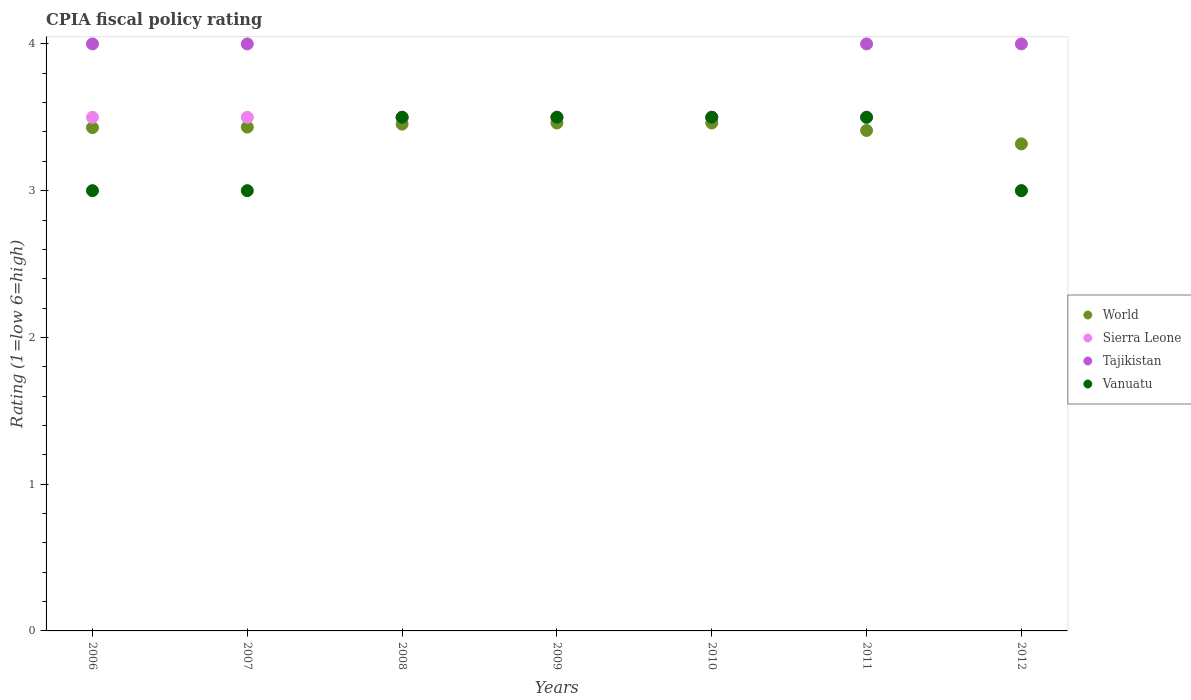Is the number of dotlines equal to the number of legend labels?
Your response must be concise. Yes. What is the CPIA rating in Vanuatu in 2010?
Your answer should be compact. 3.5. Across all years, what is the maximum CPIA rating in World?
Give a very brief answer. 3.46. Across all years, what is the minimum CPIA rating in Sierra Leone?
Ensure brevity in your answer.  3. In which year was the CPIA rating in World maximum?
Offer a very short reply. 2009. In which year was the CPIA rating in Sierra Leone minimum?
Your answer should be very brief. 2012. What is the total CPIA rating in World in the graph?
Provide a short and direct response. 23.97. What is the difference between the CPIA rating in Sierra Leone in 2008 and that in 2012?
Provide a succinct answer. 0.5. What is the average CPIA rating in World per year?
Offer a very short reply. 3.42. What is the ratio of the CPIA rating in Sierra Leone in 2008 to that in 2012?
Provide a short and direct response. 1.17. Is the CPIA rating in World in 2008 less than that in 2010?
Offer a terse response. Yes. Is the difference between the CPIA rating in Sierra Leone in 2006 and 2011 greater than the difference between the CPIA rating in Tajikistan in 2006 and 2011?
Offer a terse response. No. What is the difference between the highest and the second highest CPIA rating in World?
Provide a succinct answer. 0. What is the difference between the highest and the lowest CPIA rating in Vanuatu?
Your response must be concise. 0.5. In how many years, is the CPIA rating in Vanuatu greater than the average CPIA rating in Vanuatu taken over all years?
Offer a very short reply. 4. Is the CPIA rating in Sierra Leone strictly greater than the CPIA rating in World over the years?
Your response must be concise. No. How many years are there in the graph?
Provide a succinct answer. 7. What is the difference between two consecutive major ticks on the Y-axis?
Your answer should be compact. 1. Does the graph contain any zero values?
Offer a very short reply. No. Does the graph contain grids?
Offer a very short reply. No. Where does the legend appear in the graph?
Keep it short and to the point. Center right. How many legend labels are there?
Offer a terse response. 4. What is the title of the graph?
Your response must be concise. CPIA fiscal policy rating. What is the label or title of the Y-axis?
Provide a succinct answer. Rating (1=low 6=high). What is the Rating (1=low 6=high) of World in 2006?
Offer a very short reply. 3.43. What is the Rating (1=low 6=high) in Sierra Leone in 2006?
Your answer should be compact. 3.5. What is the Rating (1=low 6=high) of Tajikistan in 2006?
Your response must be concise. 4. What is the Rating (1=low 6=high) of World in 2007?
Ensure brevity in your answer.  3.43. What is the Rating (1=low 6=high) of Sierra Leone in 2007?
Your answer should be very brief. 3.5. What is the Rating (1=low 6=high) of Tajikistan in 2007?
Your response must be concise. 4. What is the Rating (1=low 6=high) in Vanuatu in 2007?
Your answer should be compact. 3. What is the Rating (1=low 6=high) in World in 2008?
Offer a terse response. 3.45. What is the Rating (1=low 6=high) in Tajikistan in 2008?
Offer a terse response. 3.5. What is the Rating (1=low 6=high) in Vanuatu in 2008?
Keep it short and to the point. 3.5. What is the Rating (1=low 6=high) of World in 2009?
Offer a very short reply. 3.46. What is the Rating (1=low 6=high) of World in 2010?
Offer a terse response. 3.46. What is the Rating (1=low 6=high) in Tajikistan in 2010?
Keep it short and to the point. 3.5. What is the Rating (1=low 6=high) of World in 2011?
Your answer should be very brief. 3.41. What is the Rating (1=low 6=high) of Tajikistan in 2011?
Provide a short and direct response. 4. What is the Rating (1=low 6=high) of World in 2012?
Offer a terse response. 3.32. What is the Rating (1=low 6=high) in Tajikistan in 2012?
Offer a very short reply. 4. What is the Rating (1=low 6=high) of Vanuatu in 2012?
Your response must be concise. 3. Across all years, what is the maximum Rating (1=low 6=high) in World?
Your answer should be compact. 3.46. Across all years, what is the maximum Rating (1=low 6=high) in Tajikistan?
Provide a succinct answer. 4. Across all years, what is the minimum Rating (1=low 6=high) in World?
Make the answer very short. 3.32. Across all years, what is the minimum Rating (1=low 6=high) in Sierra Leone?
Ensure brevity in your answer.  3. Across all years, what is the minimum Rating (1=low 6=high) of Vanuatu?
Keep it short and to the point. 3. What is the total Rating (1=low 6=high) in World in the graph?
Ensure brevity in your answer.  23.97. What is the difference between the Rating (1=low 6=high) of World in 2006 and that in 2007?
Your response must be concise. -0. What is the difference between the Rating (1=low 6=high) of Tajikistan in 2006 and that in 2007?
Your response must be concise. 0. What is the difference between the Rating (1=low 6=high) of World in 2006 and that in 2008?
Your response must be concise. -0.02. What is the difference between the Rating (1=low 6=high) in Tajikistan in 2006 and that in 2008?
Your answer should be very brief. 0.5. What is the difference between the Rating (1=low 6=high) of World in 2006 and that in 2009?
Give a very brief answer. -0.03. What is the difference between the Rating (1=low 6=high) of Sierra Leone in 2006 and that in 2009?
Provide a short and direct response. 0. What is the difference between the Rating (1=low 6=high) of World in 2006 and that in 2010?
Keep it short and to the point. -0.03. What is the difference between the Rating (1=low 6=high) of Sierra Leone in 2006 and that in 2010?
Ensure brevity in your answer.  0. What is the difference between the Rating (1=low 6=high) of Tajikistan in 2006 and that in 2010?
Give a very brief answer. 0.5. What is the difference between the Rating (1=low 6=high) in World in 2006 and that in 2011?
Your answer should be compact. 0.02. What is the difference between the Rating (1=low 6=high) in Sierra Leone in 2006 and that in 2011?
Provide a succinct answer. 0. What is the difference between the Rating (1=low 6=high) of Vanuatu in 2006 and that in 2011?
Your answer should be very brief. -0.5. What is the difference between the Rating (1=low 6=high) of World in 2006 and that in 2012?
Your answer should be very brief. 0.11. What is the difference between the Rating (1=low 6=high) in Tajikistan in 2006 and that in 2012?
Ensure brevity in your answer.  0. What is the difference between the Rating (1=low 6=high) in Vanuatu in 2006 and that in 2012?
Your answer should be very brief. 0. What is the difference between the Rating (1=low 6=high) in World in 2007 and that in 2008?
Provide a succinct answer. -0.02. What is the difference between the Rating (1=low 6=high) in Sierra Leone in 2007 and that in 2008?
Provide a succinct answer. 0. What is the difference between the Rating (1=low 6=high) of Tajikistan in 2007 and that in 2008?
Make the answer very short. 0.5. What is the difference between the Rating (1=low 6=high) of Vanuatu in 2007 and that in 2008?
Make the answer very short. -0.5. What is the difference between the Rating (1=low 6=high) of World in 2007 and that in 2009?
Provide a succinct answer. -0.03. What is the difference between the Rating (1=low 6=high) in Sierra Leone in 2007 and that in 2009?
Ensure brevity in your answer.  0. What is the difference between the Rating (1=low 6=high) of Tajikistan in 2007 and that in 2009?
Your answer should be compact. 0.5. What is the difference between the Rating (1=low 6=high) in World in 2007 and that in 2010?
Give a very brief answer. -0.03. What is the difference between the Rating (1=low 6=high) in Tajikistan in 2007 and that in 2010?
Offer a terse response. 0.5. What is the difference between the Rating (1=low 6=high) of Vanuatu in 2007 and that in 2010?
Your answer should be very brief. -0.5. What is the difference between the Rating (1=low 6=high) of World in 2007 and that in 2011?
Your answer should be compact. 0.02. What is the difference between the Rating (1=low 6=high) in Sierra Leone in 2007 and that in 2011?
Provide a succinct answer. 0. What is the difference between the Rating (1=low 6=high) of Tajikistan in 2007 and that in 2011?
Ensure brevity in your answer.  0. What is the difference between the Rating (1=low 6=high) of Vanuatu in 2007 and that in 2011?
Keep it short and to the point. -0.5. What is the difference between the Rating (1=low 6=high) of World in 2007 and that in 2012?
Offer a very short reply. 0.11. What is the difference between the Rating (1=low 6=high) in Tajikistan in 2007 and that in 2012?
Your response must be concise. 0. What is the difference between the Rating (1=low 6=high) in Vanuatu in 2007 and that in 2012?
Give a very brief answer. 0. What is the difference between the Rating (1=low 6=high) in World in 2008 and that in 2009?
Ensure brevity in your answer.  -0.01. What is the difference between the Rating (1=low 6=high) of World in 2008 and that in 2010?
Provide a short and direct response. -0.01. What is the difference between the Rating (1=low 6=high) in Tajikistan in 2008 and that in 2010?
Provide a succinct answer. 0. What is the difference between the Rating (1=low 6=high) in World in 2008 and that in 2011?
Provide a short and direct response. 0.04. What is the difference between the Rating (1=low 6=high) in Sierra Leone in 2008 and that in 2011?
Give a very brief answer. 0. What is the difference between the Rating (1=low 6=high) in Vanuatu in 2008 and that in 2011?
Keep it short and to the point. 0. What is the difference between the Rating (1=low 6=high) in World in 2008 and that in 2012?
Ensure brevity in your answer.  0.13. What is the difference between the Rating (1=low 6=high) of Sierra Leone in 2008 and that in 2012?
Your answer should be compact. 0.5. What is the difference between the Rating (1=low 6=high) of Vanuatu in 2008 and that in 2012?
Provide a succinct answer. 0.5. What is the difference between the Rating (1=low 6=high) in Tajikistan in 2009 and that in 2010?
Provide a succinct answer. 0. What is the difference between the Rating (1=low 6=high) in Vanuatu in 2009 and that in 2010?
Give a very brief answer. 0. What is the difference between the Rating (1=low 6=high) of World in 2009 and that in 2011?
Ensure brevity in your answer.  0.05. What is the difference between the Rating (1=low 6=high) of Tajikistan in 2009 and that in 2011?
Your answer should be compact. -0.5. What is the difference between the Rating (1=low 6=high) in Vanuatu in 2009 and that in 2011?
Offer a terse response. 0. What is the difference between the Rating (1=low 6=high) of World in 2009 and that in 2012?
Your answer should be very brief. 0.14. What is the difference between the Rating (1=low 6=high) of Sierra Leone in 2009 and that in 2012?
Keep it short and to the point. 0.5. What is the difference between the Rating (1=low 6=high) of Tajikistan in 2009 and that in 2012?
Offer a terse response. -0.5. What is the difference between the Rating (1=low 6=high) in Vanuatu in 2009 and that in 2012?
Ensure brevity in your answer.  0.5. What is the difference between the Rating (1=low 6=high) in World in 2010 and that in 2011?
Provide a short and direct response. 0.05. What is the difference between the Rating (1=low 6=high) of Sierra Leone in 2010 and that in 2011?
Your response must be concise. 0. What is the difference between the Rating (1=low 6=high) in Tajikistan in 2010 and that in 2011?
Your response must be concise. -0.5. What is the difference between the Rating (1=low 6=high) of World in 2010 and that in 2012?
Offer a very short reply. 0.14. What is the difference between the Rating (1=low 6=high) in Sierra Leone in 2010 and that in 2012?
Give a very brief answer. 0.5. What is the difference between the Rating (1=low 6=high) in Tajikistan in 2010 and that in 2012?
Offer a terse response. -0.5. What is the difference between the Rating (1=low 6=high) of Vanuatu in 2010 and that in 2012?
Your response must be concise. 0.5. What is the difference between the Rating (1=low 6=high) of World in 2011 and that in 2012?
Ensure brevity in your answer.  0.09. What is the difference between the Rating (1=low 6=high) of Sierra Leone in 2011 and that in 2012?
Your answer should be compact. 0.5. What is the difference between the Rating (1=low 6=high) of Tajikistan in 2011 and that in 2012?
Your response must be concise. 0. What is the difference between the Rating (1=low 6=high) in Vanuatu in 2011 and that in 2012?
Keep it short and to the point. 0.5. What is the difference between the Rating (1=low 6=high) of World in 2006 and the Rating (1=low 6=high) of Sierra Leone in 2007?
Provide a short and direct response. -0.07. What is the difference between the Rating (1=low 6=high) of World in 2006 and the Rating (1=low 6=high) of Tajikistan in 2007?
Make the answer very short. -0.57. What is the difference between the Rating (1=low 6=high) in World in 2006 and the Rating (1=low 6=high) in Vanuatu in 2007?
Your answer should be compact. 0.43. What is the difference between the Rating (1=low 6=high) of Sierra Leone in 2006 and the Rating (1=low 6=high) of Vanuatu in 2007?
Your response must be concise. 0.5. What is the difference between the Rating (1=low 6=high) in World in 2006 and the Rating (1=low 6=high) in Sierra Leone in 2008?
Your response must be concise. -0.07. What is the difference between the Rating (1=low 6=high) in World in 2006 and the Rating (1=low 6=high) in Tajikistan in 2008?
Give a very brief answer. -0.07. What is the difference between the Rating (1=low 6=high) in World in 2006 and the Rating (1=low 6=high) in Vanuatu in 2008?
Provide a succinct answer. -0.07. What is the difference between the Rating (1=low 6=high) in Sierra Leone in 2006 and the Rating (1=low 6=high) in Tajikistan in 2008?
Give a very brief answer. 0. What is the difference between the Rating (1=low 6=high) in World in 2006 and the Rating (1=low 6=high) in Sierra Leone in 2009?
Provide a succinct answer. -0.07. What is the difference between the Rating (1=low 6=high) of World in 2006 and the Rating (1=low 6=high) of Tajikistan in 2009?
Ensure brevity in your answer.  -0.07. What is the difference between the Rating (1=low 6=high) in World in 2006 and the Rating (1=low 6=high) in Vanuatu in 2009?
Keep it short and to the point. -0.07. What is the difference between the Rating (1=low 6=high) in World in 2006 and the Rating (1=low 6=high) in Sierra Leone in 2010?
Ensure brevity in your answer.  -0.07. What is the difference between the Rating (1=low 6=high) of World in 2006 and the Rating (1=low 6=high) of Tajikistan in 2010?
Offer a very short reply. -0.07. What is the difference between the Rating (1=low 6=high) in World in 2006 and the Rating (1=low 6=high) in Vanuatu in 2010?
Your answer should be very brief. -0.07. What is the difference between the Rating (1=low 6=high) of Sierra Leone in 2006 and the Rating (1=low 6=high) of Tajikistan in 2010?
Provide a succinct answer. 0. What is the difference between the Rating (1=low 6=high) in Sierra Leone in 2006 and the Rating (1=low 6=high) in Vanuatu in 2010?
Your answer should be very brief. 0. What is the difference between the Rating (1=low 6=high) in World in 2006 and the Rating (1=low 6=high) in Sierra Leone in 2011?
Offer a terse response. -0.07. What is the difference between the Rating (1=low 6=high) in World in 2006 and the Rating (1=low 6=high) in Tajikistan in 2011?
Provide a succinct answer. -0.57. What is the difference between the Rating (1=low 6=high) in World in 2006 and the Rating (1=low 6=high) in Vanuatu in 2011?
Your answer should be very brief. -0.07. What is the difference between the Rating (1=low 6=high) in Sierra Leone in 2006 and the Rating (1=low 6=high) in Tajikistan in 2011?
Ensure brevity in your answer.  -0.5. What is the difference between the Rating (1=low 6=high) of Sierra Leone in 2006 and the Rating (1=low 6=high) of Vanuatu in 2011?
Offer a very short reply. 0. What is the difference between the Rating (1=low 6=high) of World in 2006 and the Rating (1=low 6=high) of Sierra Leone in 2012?
Your answer should be compact. 0.43. What is the difference between the Rating (1=low 6=high) in World in 2006 and the Rating (1=low 6=high) in Tajikistan in 2012?
Your answer should be compact. -0.57. What is the difference between the Rating (1=low 6=high) of World in 2006 and the Rating (1=low 6=high) of Vanuatu in 2012?
Your response must be concise. 0.43. What is the difference between the Rating (1=low 6=high) of World in 2007 and the Rating (1=low 6=high) of Sierra Leone in 2008?
Your response must be concise. -0.07. What is the difference between the Rating (1=low 6=high) of World in 2007 and the Rating (1=low 6=high) of Tajikistan in 2008?
Your answer should be compact. -0.07. What is the difference between the Rating (1=low 6=high) in World in 2007 and the Rating (1=low 6=high) in Vanuatu in 2008?
Offer a terse response. -0.07. What is the difference between the Rating (1=low 6=high) of Sierra Leone in 2007 and the Rating (1=low 6=high) of Tajikistan in 2008?
Make the answer very short. 0. What is the difference between the Rating (1=low 6=high) in Sierra Leone in 2007 and the Rating (1=low 6=high) in Vanuatu in 2008?
Offer a terse response. 0. What is the difference between the Rating (1=low 6=high) of Tajikistan in 2007 and the Rating (1=low 6=high) of Vanuatu in 2008?
Your response must be concise. 0.5. What is the difference between the Rating (1=low 6=high) in World in 2007 and the Rating (1=low 6=high) in Sierra Leone in 2009?
Offer a terse response. -0.07. What is the difference between the Rating (1=low 6=high) of World in 2007 and the Rating (1=low 6=high) of Tajikistan in 2009?
Make the answer very short. -0.07. What is the difference between the Rating (1=low 6=high) in World in 2007 and the Rating (1=low 6=high) in Vanuatu in 2009?
Keep it short and to the point. -0.07. What is the difference between the Rating (1=low 6=high) in Sierra Leone in 2007 and the Rating (1=low 6=high) in Tajikistan in 2009?
Your answer should be compact. 0. What is the difference between the Rating (1=low 6=high) in Sierra Leone in 2007 and the Rating (1=low 6=high) in Vanuatu in 2009?
Your response must be concise. 0. What is the difference between the Rating (1=low 6=high) of Tajikistan in 2007 and the Rating (1=low 6=high) of Vanuatu in 2009?
Make the answer very short. 0.5. What is the difference between the Rating (1=low 6=high) in World in 2007 and the Rating (1=low 6=high) in Sierra Leone in 2010?
Provide a short and direct response. -0.07. What is the difference between the Rating (1=low 6=high) of World in 2007 and the Rating (1=low 6=high) of Tajikistan in 2010?
Your response must be concise. -0.07. What is the difference between the Rating (1=low 6=high) in World in 2007 and the Rating (1=low 6=high) in Vanuatu in 2010?
Ensure brevity in your answer.  -0.07. What is the difference between the Rating (1=low 6=high) in Sierra Leone in 2007 and the Rating (1=low 6=high) in Tajikistan in 2010?
Offer a terse response. 0. What is the difference between the Rating (1=low 6=high) of World in 2007 and the Rating (1=low 6=high) of Sierra Leone in 2011?
Provide a short and direct response. -0.07. What is the difference between the Rating (1=low 6=high) in World in 2007 and the Rating (1=low 6=high) in Tajikistan in 2011?
Give a very brief answer. -0.57. What is the difference between the Rating (1=low 6=high) in World in 2007 and the Rating (1=low 6=high) in Vanuatu in 2011?
Provide a succinct answer. -0.07. What is the difference between the Rating (1=low 6=high) of World in 2007 and the Rating (1=low 6=high) of Sierra Leone in 2012?
Make the answer very short. 0.43. What is the difference between the Rating (1=low 6=high) in World in 2007 and the Rating (1=low 6=high) in Tajikistan in 2012?
Offer a very short reply. -0.57. What is the difference between the Rating (1=low 6=high) of World in 2007 and the Rating (1=low 6=high) of Vanuatu in 2012?
Offer a terse response. 0.43. What is the difference between the Rating (1=low 6=high) in Sierra Leone in 2007 and the Rating (1=low 6=high) in Tajikistan in 2012?
Offer a terse response. -0.5. What is the difference between the Rating (1=low 6=high) of Sierra Leone in 2007 and the Rating (1=low 6=high) of Vanuatu in 2012?
Ensure brevity in your answer.  0.5. What is the difference between the Rating (1=low 6=high) of World in 2008 and the Rating (1=low 6=high) of Sierra Leone in 2009?
Offer a very short reply. -0.05. What is the difference between the Rating (1=low 6=high) in World in 2008 and the Rating (1=low 6=high) in Tajikistan in 2009?
Your response must be concise. -0.05. What is the difference between the Rating (1=low 6=high) of World in 2008 and the Rating (1=low 6=high) of Vanuatu in 2009?
Your answer should be very brief. -0.05. What is the difference between the Rating (1=low 6=high) of Sierra Leone in 2008 and the Rating (1=low 6=high) of Tajikistan in 2009?
Ensure brevity in your answer.  0. What is the difference between the Rating (1=low 6=high) of World in 2008 and the Rating (1=low 6=high) of Sierra Leone in 2010?
Your answer should be compact. -0.05. What is the difference between the Rating (1=low 6=high) of World in 2008 and the Rating (1=low 6=high) of Tajikistan in 2010?
Your response must be concise. -0.05. What is the difference between the Rating (1=low 6=high) of World in 2008 and the Rating (1=low 6=high) of Vanuatu in 2010?
Give a very brief answer. -0.05. What is the difference between the Rating (1=low 6=high) in World in 2008 and the Rating (1=low 6=high) in Sierra Leone in 2011?
Ensure brevity in your answer.  -0.05. What is the difference between the Rating (1=low 6=high) in World in 2008 and the Rating (1=low 6=high) in Tajikistan in 2011?
Your answer should be compact. -0.55. What is the difference between the Rating (1=low 6=high) of World in 2008 and the Rating (1=low 6=high) of Vanuatu in 2011?
Make the answer very short. -0.05. What is the difference between the Rating (1=low 6=high) of Sierra Leone in 2008 and the Rating (1=low 6=high) of Tajikistan in 2011?
Offer a very short reply. -0.5. What is the difference between the Rating (1=low 6=high) in Sierra Leone in 2008 and the Rating (1=low 6=high) in Vanuatu in 2011?
Keep it short and to the point. 0. What is the difference between the Rating (1=low 6=high) of World in 2008 and the Rating (1=low 6=high) of Sierra Leone in 2012?
Ensure brevity in your answer.  0.45. What is the difference between the Rating (1=low 6=high) of World in 2008 and the Rating (1=low 6=high) of Tajikistan in 2012?
Provide a succinct answer. -0.55. What is the difference between the Rating (1=low 6=high) of World in 2008 and the Rating (1=low 6=high) of Vanuatu in 2012?
Give a very brief answer. 0.45. What is the difference between the Rating (1=low 6=high) in Sierra Leone in 2008 and the Rating (1=low 6=high) in Vanuatu in 2012?
Provide a succinct answer. 0.5. What is the difference between the Rating (1=low 6=high) of World in 2009 and the Rating (1=low 6=high) of Sierra Leone in 2010?
Keep it short and to the point. -0.04. What is the difference between the Rating (1=low 6=high) of World in 2009 and the Rating (1=low 6=high) of Tajikistan in 2010?
Give a very brief answer. -0.04. What is the difference between the Rating (1=low 6=high) in World in 2009 and the Rating (1=low 6=high) in Vanuatu in 2010?
Keep it short and to the point. -0.04. What is the difference between the Rating (1=low 6=high) in Sierra Leone in 2009 and the Rating (1=low 6=high) in Tajikistan in 2010?
Provide a succinct answer. 0. What is the difference between the Rating (1=low 6=high) of Sierra Leone in 2009 and the Rating (1=low 6=high) of Vanuatu in 2010?
Ensure brevity in your answer.  0. What is the difference between the Rating (1=low 6=high) of Tajikistan in 2009 and the Rating (1=low 6=high) of Vanuatu in 2010?
Give a very brief answer. 0. What is the difference between the Rating (1=low 6=high) of World in 2009 and the Rating (1=low 6=high) of Sierra Leone in 2011?
Your answer should be compact. -0.04. What is the difference between the Rating (1=low 6=high) in World in 2009 and the Rating (1=low 6=high) in Tajikistan in 2011?
Your answer should be very brief. -0.54. What is the difference between the Rating (1=low 6=high) of World in 2009 and the Rating (1=low 6=high) of Vanuatu in 2011?
Offer a terse response. -0.04. What is the difference between the Rating (1=low 6=high) in Sierra Leone in 2009 and the Rating (1=low 6=high) in Vanuatu in 2011?
Provide a succinct answer. 0. What is the difference between the Rating (1=low 6=high) in Tajikistan in 2009 and the Rating (1=low 6=high) in Vanuatu in 2011?
Provide a succinct answer. 0. What is the difference between the Rating (1=low 6=high) of World in 2009 and the Rating (1=low 6=high) of Sierra Leone in 2012?
Ensure brevity in your answer.  0.46. What is the difference between the Rating (1=low 6=high) in World in 2009 and the Rating (1=low 6=high) in Tajikistan in 2012?
Provide a succinct answer. -0.54. What is the difference between the Rating (1=low 6=high) of World in 2009 and the Rating (1=low 6=high) of Vanuatu in 2012?
Your response must be concise. 0.46. What is the difference between the Rating (1=low 6=high) in Sierra Leone in 2009 and the Rating (1=low 6=high) in Tajikistan in 2012?
Offer a very short reply. -0.5. What is the difference between the Rating (1=low 6=high) in World in 2010 and the Rating (1=low 6=high) in Sierra Leone in 2011?
Provide a succinct answer. -0.04. What is the difference between the Rating (1=low 6=high) of World in 2010 and the Rating (1=low 6=high) of Tajikistan in 2011?
Provide a succinct answer. -0.54. What is the difference between the Rating (1=low 6=high) in World in 2010 and the Rating (1=low 6=high) in Vanuatu in 2011?
Your answer should be very brief. -0.04. What is the difference between the Rating (1=low 6=high) of Sierra Leone in 2010 and the Rating (1=low 6=high) of Tajikistan in 2011?
Your response must be concise. -0.5. What is the difference between the Rating (1=low 6=high) in World in 2010 and the Rating (1=low 6=high) in Sierra Leone in 2012?
Provide a short and direct response. 0.46. What is the difference between the Rating (1=low 6=high) in World in 2010 and the Rating (1=low 6=high) in Tajikistan in 2012?
Ensure brevity in your answer.  -0.54. What is the difference between the Rating (1=low 6=high) of World in 2010 and the Rating (1=low 6=high) of Vanuatu in 2012?
Make the answer very short. 0.46. What is the difference between the Rating (1=low 6=high) in Sierra Leone in 2010 and the Rating (1=low 6=high) in Tajikistan in 2012?
Ensure brevity in your answer.  -0.5. What is the difference between the Rating (1=low 6=high) of Sierra Leone in 2010 and the Rating (1=low 6=high) of Vanuatu in 2012?
Your response must be concise. 0.5. What is the difference between the Rating (1=low 6=high) of Tajikistan in 2010 and the Rating (1=low 6=high) of Vanuatu in 2012?
Your answer should be compact. 0.5. What is the difference between the Rating (1=low 6=high) of World in 2011 and the Rating (1=low 6=high) of Sierra Leone in 2012?
Your answer should be compact. 0.41. What is the difference between the Rating (1=low 6=high) of World in 2011 and the Rating (1=low 6=high) of Tajikistan in 2012?
Your answer should be very brief. -0.59. What is the difference between the Rating (1=low 6=high) in World in 2011 and the Rating (1=low 6=high) in Vanuatu in 2012?
Provide a succinct answer. 0.41. What is the average Rating (1=low 6=high) of World per year?
Provide a succinct answer. 3.42. What is the average Rating (1=low 6=high) of Sierra Leone per year?
Provide a succinct answer. 3.43. What is the average Rating (1=low 6=high) in Tajikistan per year?
Offer a terse response. 3.79. What is the average Rating (1=low 6=high) in Vanuatu per year?
Your answer should be very brief. 3.29. In the year 2006, what is the difference between the Rating (1=low 6=high) of World and Rating (1=low 6=high) of Sierra Leone?
Ensure brevity in your answer.  -0.07. In the year 2006, what is the difference between the Rating (1=low 6=high) of World and Rating (1=low 6=high) of Tajikistan?
Make the answer very short. -0.57. In the year 2006, what is the difference between the Rating (1=low 6=high) of World and Rating (1=low 6=high) of Vanuatu?
Provide a short and direct response. 0.43. In the year 2007, what is the difference between the Rating (1=low 6=high) in World and Rating (1=low 6=high) in Sierra Leone?
Ensure brevity in your answer.  -0.07. In the year 2007, what is the difference between the Rating (1=low 6=high) of World and Rating (1=low 6=high) of Tajikistan?
Provide a short and direct response. -0.57. In the year 2007, what is the difference between the Rating (1=low 6=high) of World and Rating (1=low 6=high) of Vanuatu?
Your answer should be compact. 0.43. In the year 2007, what is the difference between the Rating (1=low 6=high) in Sierra Leone and Rating (1=low 6=high) in Vanuatu?
Give a very brief answer. 0.5. In the year 2007, what is the difference between the Rating (1=low 6=high) in Tajikistan and Rating (1=low 6=high) in Vanuatu?
Provide a short and direct response. 1. In the year 2008, what is the difference between the Rating (1=low 6=high) of World and Rating (1=low 6=high) of Sierra Leone?
Make the answer very short. -0.05. In the year 2008, what is the difference between the Rating (1=low 6=high) of World and Rating (1=low 6=high) of Tajikistan?
Keep it short and to the point. -0.05. In the year 2008, what is the difference between the Rating (1=low 6=high) in World and Rating (1=low 6=high) in Vanuatu?
Give a very brief answer. -0.05. In the year 2009, what is the difference between the Rating (1=low 6=high) in World and Rating (1=low 6=high) in Sierra Leone?
Provide a succinct answer. -0.04. In the year 2009, what is the difference between the Rating (1=low 6=high) of World and Rating (1=low 6=high) of Tajikistan?
Provide a short and direct response. -0.04. In the year 2009, what is the difference between the Rating (1=low 6=high) of World and Rating (1=low 6=high) of Vanuatu?
Give a very brief answer. -0.04. In the year 2009, what is the difference between the Rating (1=low 6=high) of Sierra Leone and Rating (1=low 6=high) of Tajikistan?
Keep it short and to the point. 0. In the year 2009, what is the difference between the Rating (1=low 6=high) of Tajikistan and Rating (1=low 6=high) of Vanuatu?
Keep it short and to the point. 0. In the year 2010, what is the difference between the Rating (1=low 6=high) of World and Rating (1=low 6=high) of Sierra Leone?
Provide a short and direct response. -0.04. In the year 2010, what is the difference between the Rating (1=low 6=high) in World and Rating (1=low 6=high) in Tajikistan?
Give a very brief answer. -0.04. In the year 2010, what is the difference between the Rating (1=low 6=high) of World and Rating (1=low 6=high) of Vanuatu?
Ensure brevity in your answer.  -0.04. In the year 2010, what is the difference between the Rating (1=low 6=high) in Sierra Leone and Rating (1=low 6=high) in Tajikistan?
Provide a succinct answer. 0. In the year 2010, what is the difference between the Rating (1=low 6=high) of Sierra Leone and Rating (1=low 6=high) of Vanuatu?
Offer a terse response. 0. In the year 2010, what is the difference between the Rating (1=low 6=high) in Tajikistan and Rating (1=low 6=high) in Vanuatu?
Provide a succinct answer. 0. In the year 2011, what is the difference between the Rating (1=low 6=high) of World and Rating (1=low 6=high) of Sierra Leone?
Offer a very short reply. -0.09. In the year 2011, what is the difference between the Rating (1=low 6=high) of World and Rating (1=low 6=high) of Tajikistan?
Offer a terse response. -0.59. In the year 2011, what is the difference between the Rating (1=low 6=high) in World and Rating (1=low 6=high) in Vanuatu?
Make the answer very short. -0.09. In the year 2011, what is the difference between the Rating (1=low 6=high) in Sierra Leone and Rating (1=low 6=high) in Tajikistan?
Your answer should be compact. -0.5. In the year 2011, what is the difference between the Rating (1=low 6=high) of Sierra Leone and Rating (1=low 6=high) of Vanuatu?
Provide a succinct answer. 0. In the year 2011, what is the difference between the Rating (1=low 6=high) in Tajikistan and Rating (1=low 6=high) in Vanuatu?
Ensure brevity in your answer.  0.5. In the year 2012, what is the difference between the Rating (1=low 6=high) of World and Rating (1=low 6=high) of Sierra Leone?
Offer a terse response. 0.32. In the year 2012, what is the difference between the Rating (1=low 6=high) in World and Rating (1=low 6=high) in Tajikistan?
Your answer should be compact. -0.68. In the year 2012, what is the difference between the Rating (1=low 6=high) of World and Rating (1=low 6=high) of Vanuatu?
Ensure brevity in your answer.  0.32. What is the ratio of the Rating (1=low 6=high) of Sierra Leone in 2006 to that in 2007?
Make the answer very short. 1. What is the ratio of the Rating (1=low 6=high) of Vanuatu in 2006 to that in 2007?
Make the answer very short. 1. What is the ratio of the Rating (1=low 6=high) of Sierra Leone in 2006 to that in 2008?
Offer a terse response. 1. What is the ratio of the Rating (1=low 6=high) of Tajikistan in 2006 to that in 2008?
Ensure brevity in your answer.  1.14. What is the ratio of the Rating (1=low 6=high) in Vanuatu in 2006 to that in 2008?
Keep it short and to the point. 0.86. What is the ratio of the Rating (1=low 6=high) in World in 2006 to that in 2009?
Give a very brief answer. 0.99. What is the ratio of the Rating (1=low 6=high) of Sierra Leone in 2006 to that in 2009?
Give a very brief answer. 1. What is the ratio of the Rating (1=low 6=high) in Vanuatu in 2006 to that in 2009?
Keep it short and to the point. 0.86. What is the ratio of the Rating (1=low 6=high) of World in 2006 to that in 2010?
Ensure brevity in your answer.  0.99. What is the ratio of the Rating (1=low 6=high) in Vanuatu in 2006 to that in 2010?
Keep it short and to the point. 0.86. What is the ratio of the Rating (1=low 6=high) in World in 2006 to that in 2011?
Keep it short and to the point. 1.01. What is the ratio of the Rating (1=low 6=high) in Sierra Leone in 2006 to that in 2011?
Offer a very short reply. 1. What is the ratio of the Rating (1=low 6=high) of Tajikistan in 2006 to that in 2011?
Your answer should be very brief. 1. What is the ratio of the Rating (1=low 6=high) of World in 2006 to that in 2012?
Offer a very short reply. 1.03. What is the ratio of the Rating (1=low 6=high) of World in 2007 to that in 2008?
Your response must be concise. 0.99. What is the ratio of the Rating (1=low 6=high) of Tajikistan in 2007 to that in 2008?
Provide a succinct answer. 1.14. What is the ratio of the Rating (1=low 6=high) in World in 2007 to that in 2009?
Make the answer very short. 0.99. What is the ratio of the Rating (1=low 6=high) of Vanuatu in 2007 to that in 2009?
Ensure brevity in your answer.  0.86. What is the ratio of the Rating (1=low 6=high) of World in 2007 to that in 2010?
Provide a short and direct response. 0.99. What is the ratio of the Rating (1=low 6=high) in Sierra Leone in 2007 to that in 2010?
Provide a succinct answer. 1. What is the ratio of the Rating (1=low 6=high) in Tajikistan in 2007 to that in 2010?
Your response must be concise. 1.14. What is the ratio of the Rating (1=low 6=high) of World in 2007 to that in 2011?
Offer a terse response. 1.01. What is the ratio of the Rating (1=low 6=high) in World in 2007 to that in 2012?
Your response must be concise. 1.03. What is the ratio of the Rating (1=low 6=high) of Sierra Leone in 2008 to that in 2010?
Provide a succinct answer. 1. What is the ratio of the Rating (1=low 6=high) of Tajikistan in 2008 to that in 2010?
Ensure brevity in your answer.  1. What is the ratio of the Rating (1=low 6=high) in World in 2008 to that in 2011?
Keep it short and to the point. 1.01. What is the ratio of the Rating (1=low 6=high) in Tajikistan in 2008 to that in 2011?
Keep it short and to the point. 0.88. What is the ratio of the Rating (1=low 6=high) of World in 2008 to that in 2012?
Your answer should be very brief. 1.04. What is the ratio of the Rating (1=low 6=high) in Sierra Leone in 2008 to that in 2012?
Offer a terse response. 1.17. What is the ratio of the Rating (1=low 6=high) in Tajikistan in 2008 to that in 2012?
Your answer should be compact. 0.88. What is the ratio of the Rating (1=low 6=high) of Vanuatu in 2008 to that in 2012?
Provide a succinct answer. 1.17. What is the ratio of the Rating (1=low 6=high) of Tajikistan in 2009 to that in 2010?
Provide a succinct answer. 1. What is the ratio of the Rating (1=low 6=high) of Vanuatu in 2009 to that in 2010?
Ensure brevity in your answer.  1. What is the ratio of the Rating (1=low 6=high) of World in 2009 to that in 2011?
Provide a short and direct response. 1.01. What is the ratio of the Rating (1=low 6=high) in Tajikistan in 2009 to that in 2011?
Ensure brevity in your answer.  0.88. What is the ratio of the Rating (1=low 6=high) of World in 2009 to that in 2012?
Your answer should be very brief. 1.04. What is the ratio of the Rating (1=low 6=high) in Tajikistan in 2009 to that in 2012?
Offer a terse response. 0.88. What is the ratio of the Rating (1=low 6=high) of World in 2010 to that in 2011?
Provide a succinct answer. 1.01. What is the ratio of the Rating (1=low 6=high) of Sierra Leone in 2010 to that in 2011?
Ensure brevity in your answer.  1. What is the ratio of the Rating (1=low 6=high) of Vanuatu in 2010 to that in 2011?
Give a very brief answer. 1. What is the ratio of the Rating (1=low 6=high) of World in 2010 to that in 2012?
Your answer should be very brief. 1.04. What is the ratio of the Rating (1=low 6=high) of Sierra Leone in 2010 to that in 2012?
Your answer should be compact. 1.17. What is the ratio of the Rating (1=low 6=high) in World in 2011 to that in 2012?
Your response must be concise. 1.03. What is the ratio of the Rating (1=low 6=high) of Sierra Leone in 2011 to that in 2012?
Provide a succinct answer. 1.17. What is the ratio of the Rating (1=low 6=high) in Tajikistan in 2011 to that in 2012?
Make the answer very short. 1. What is the difference between the highest and the second highest Rating (1=low 6=high) of World?
Offer a terse response. 0. What is the difference between the highest and the second highest Rating (1=low 6=high) of Vanuatu?
Keep it short and to the point. 0. What is the difference between the highest and the lowest Rating (1=low 6=high) of World?
Offer a very short reply. 0.14. What is the difference between the highest and the lowest Rating (1=low 6=high) of Sierra Leone?
Offer a terse response. 0.5. What is the difference between the highest and the lowest Rating (1=low 6=high) in Vanuatu?
Ensure brevity in your answer.  0.5. 